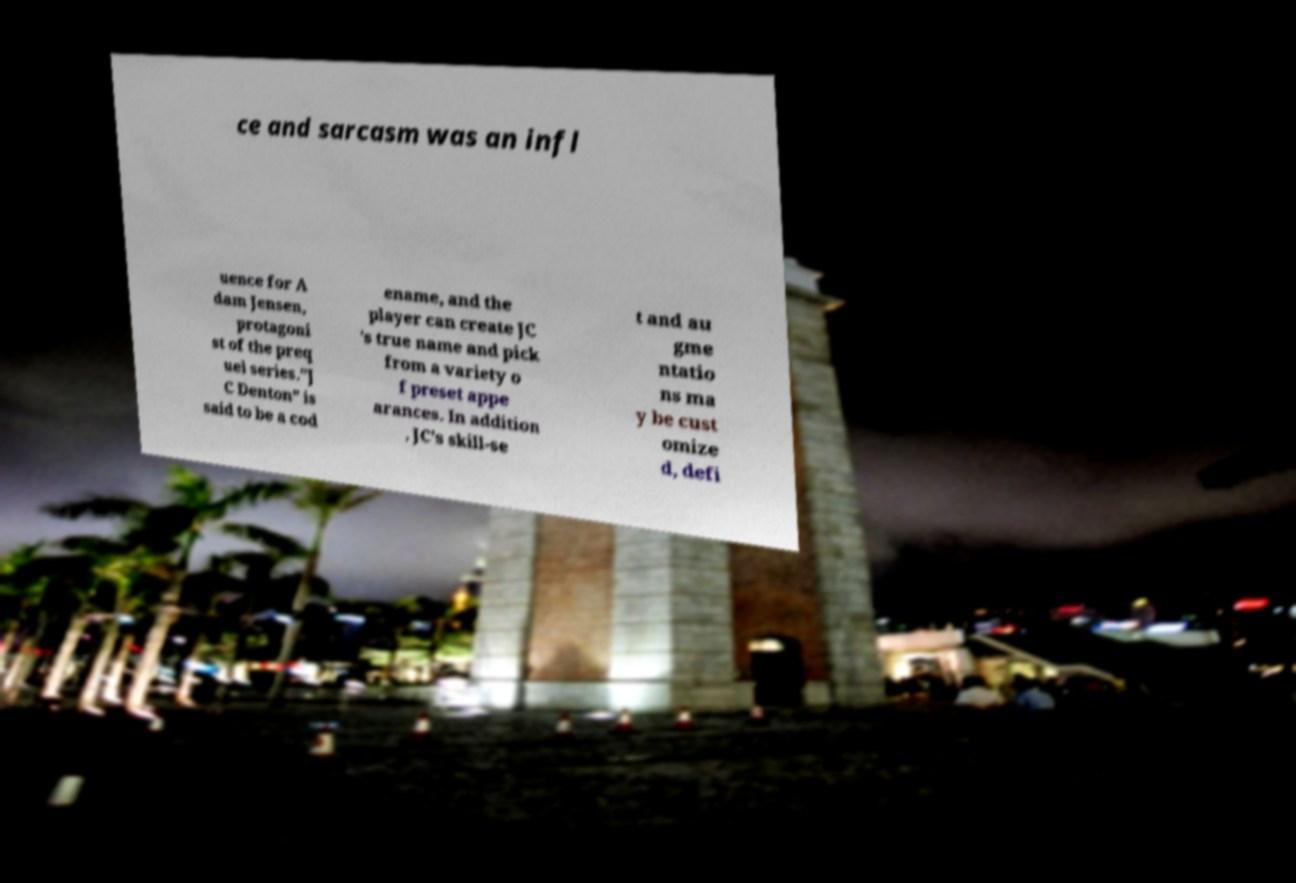I need the written content from this picture converted into text. Can you do that? ce and sarcasm was an infl uence for A dam Jensen, protagoni st of the preq uel series."J C Denton" is said to be a cod ename, and the player can create JC 's true name and pick from a variety o f preset appe arances. In addition , JC's skill-se t and au gme ntatio ns ma y be cust omize d, defi 